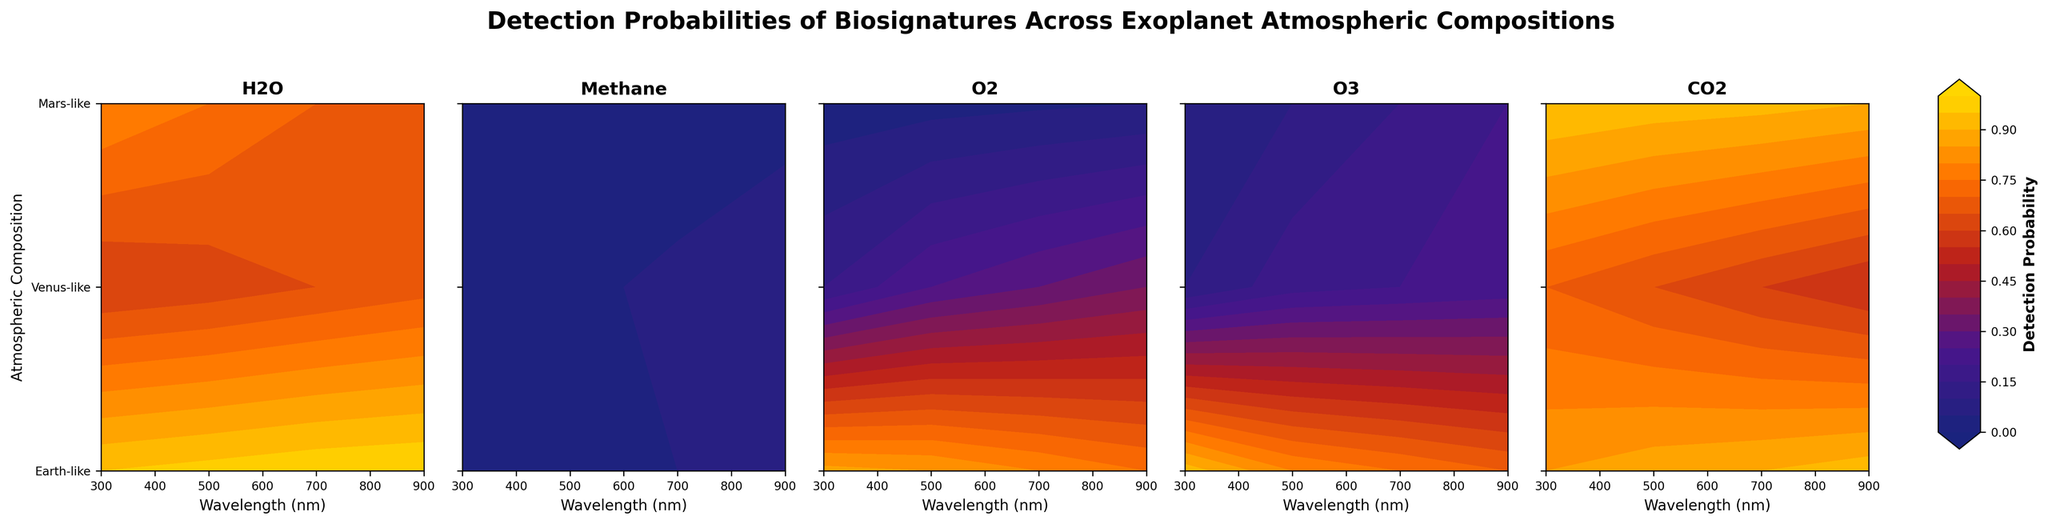How many different atmospheric compositions are considered in this study? Examine the y-axis labels. There are three different atmospheric compositions labeled: Earth-like, Venus-like, and Mars-like.
Answer: 3 What is the detection probability of H2O at 900 nm for an Earth-like atmosphere? Locate the subplot titled 'H2O' and find the point at 900 nm on the x-axis for Earth-like on the y-axis. The color code and contour labels show a detection probability of 1.00.
Answer: 1.00 Which biosignature has the lowest detection probability in a Mars-like atmosphere at 300 nm? For each subplot, identify the detection probabilities at 300 nm for Mars-like on the y-axis. Methane has the lowest detection probability of 0.03.
Answer: Methane How does the detection probability of O3 in a Venus-like atmosphere vary with wavelength? Look at the subplot titled 'O3' and trace the values for Venus-like across different wavelengths (300, 500, 700, 900 nm). The probabilities are 0.05, 0.10, 0.15, and 0.20 respectively, showing a gradual increase with wavelength.
Answer: Increases In which atmospheric composition is the detection probability of CO2 higher at 500 nm compared to 300 nm? Examine the subplot titled 'CO2' for the values in each atmospheric composition at 300 nm and 500 nm. In Earth-like and Venus-like compositions, the detection probability at 500 nm (0.88 and 0.93) is higher than at 300 nm (0.85 and 0.95).
Answer: Earth-like and Venus-like Compare the detection probabilities of O2 at 700 nm in Earth-like and Mars-like atmospheres. Which one is higher? Look at the subplot titled 'O2' and compare the values at 700 nm for Earth-like and Mars-like compositions. Earth-like has 0.80 while Mars-like has 0.30, so Earth-like is higher.
Answer: Earth-like What trends can be observed in the detection probability of Methane across all atmospheric compositions as wavelength increases? Observe the subplot titled 'Methane' for each atmospheric composition. Probabilities for Earth-like increase from 0.02 to 0.08, Venus-like increases from 0.01 to 0.04, and Mars-like increases from 0.03 to 0.07. All show a slight upward trend.
Answer: Increasing trend What's the average detection probability of O3 in a Mars-like atmosphere across all wavelengths? Add the detection probabilities of O3 in a Mars-like atmosphere (0.10, 0.18, 0.20, 0.22) and divide by 4. (0.10 + 0.18 + 0.20 + 0.22) / 4 = 0.175
Answer: 0.175 Which atmospheric composition consistently shows the highest detection probabilities for H2O across all wavelengths? In the subplot titled 'H2O', compare detection probabilities across all wavelengths for each composition. Earth-like shows higher probabilities (0.95, 0.97, 0.99, 1.00) consistently.
Answer: Earth-like 